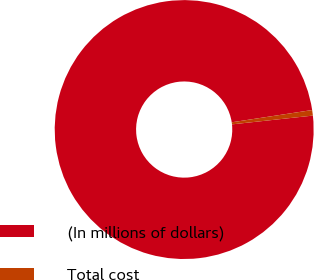<chart> <loc_0><loc_0><loc_500><loc_500><pie_chart><fcel>(In millions of dollars)<fcel>Total cost<nl><fcel>99.31%<fcel>0.69%<nl></chart> 